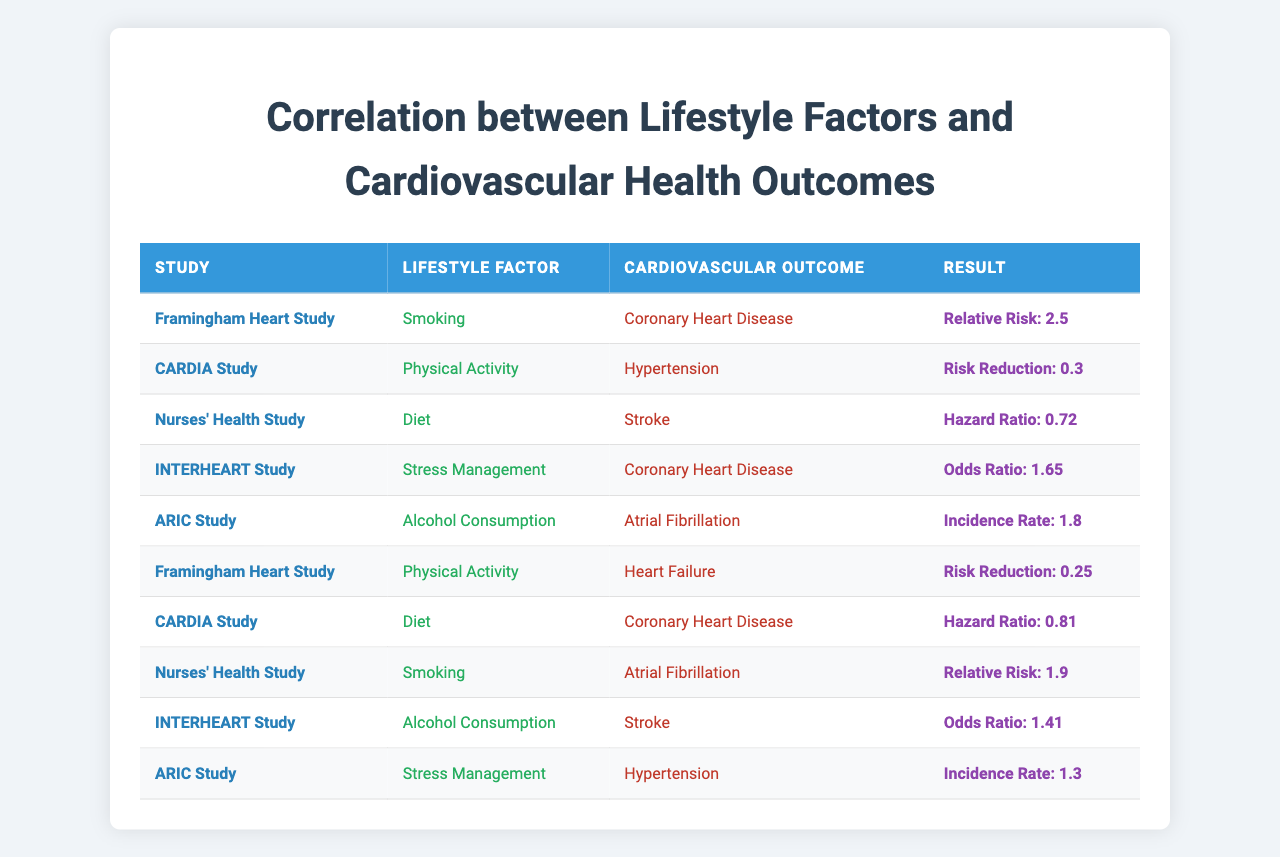What is the relative risk of developing Coronary Heart Disease from Smoking according to the Framingham Heart Study? The table shows that in the Framingham Heart Study, the relative risk for developing Coronary Heart Disease from Smoking is 2.5.
Answer: 2.5 Which lifestyle factor is associated with risk reduction for Hypertension in the CARDIA Study? The CARDIA Study associates Physical Activity with a risk reduction of 0.3 for Hypertension.
Answer: Physical Activity What is the hazard ratio for Diet and its effect on Stroke in the Nurses' Health Study? According to the Nurses' Health Study, the hazard ratio for Diet affecting Stroke is 0.72.
Answer: 0.72 Is there a higher odds ratio for Alcohol Consumption affecting Stroke or for Stress Management affecting Coronary Heart Disease in the INTERHEART Study? The odds ratio for Alcohol Consumption affecting Stroke is 1.41, while for Stress Management affecting Coronary Heart Disease it is 1.65. Since 1.65 is greater than 1.41, Stress Management has a higher odds ratio.
Answer: Yes, Stress Management has a higher odds ratio What is the incidence rate for Alcohol Consumption related to Atrial Fibrillation in the ARIC Study? The table indicates that in the ARIC Study, the incidence rate for Alcohol Consumption related to Atrial Fibrillation is 1.8.
Answer: 1.8 When comparing the hazard ratios of Diet in the CARDIA Study and Nurses' Health Study, which is lower? The hazard ratio for Diet in the CARDIA Study is 0.81, whereas it is 0.72 in the Nurses' Health Study. Since 0.72 is lower than 0.81, the Nurses' Health Study has a lower hazard ratio.
Answer: Nurses' Health Study What percentage reduction in risk is associated with Physical Activity for Heart Failure in the Framingham Heart Study? The risk reduction associated with Physical Activity for Heart Failure in the Framingham Heart Study is 0.25, which indicates a 25% reduction in risk.
Answer: 25% Which study associates Stress Management with a higher incidence rate for Hypertension, ARIC Study or INTERHEART Study? The ARIC Study links Stress Management to an incidence rate of 1.3 for Hypertension, while the INTERHEART Study does not list an incidence rate for Stress Management. Therefore, ARIC Study has the available data for comparison.
Answer: ARIC Study If someone stops smoking, how much relative risk decrease do they experience according to the Framingham Heart Study? The Framingham Heart Study indicates that the relative risk from Smoking is 2.5; thus, stopping smoking would lead to a decrease from this value but the exact decrease would depend on the individual circumstances and other factors not specified in the table.
Answer: Decrease from 2.5 (exact number not specified) What is the trend seen in physical activity and its relation to heart failure across studies? In the Framingham Heart Study, higher Physical Activity led to a risk reduction of 0.25 for Heart Failure. This suggests that increased Physical Activity generally relates to lower risk of heart failure, indicating a positive trend for cardiovascular health outcomes.
Answer: Positive trend for heart health 